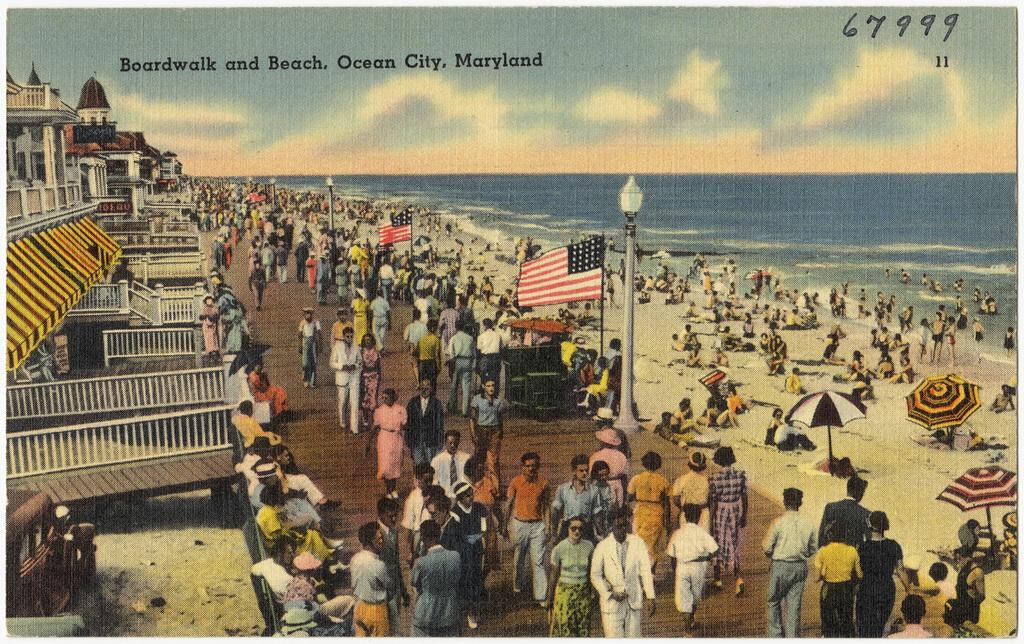<image>
Offer a succinct explanation of the picture presented. Postcard showing people at a boardwalk and says "Ocean City, Maryland". 